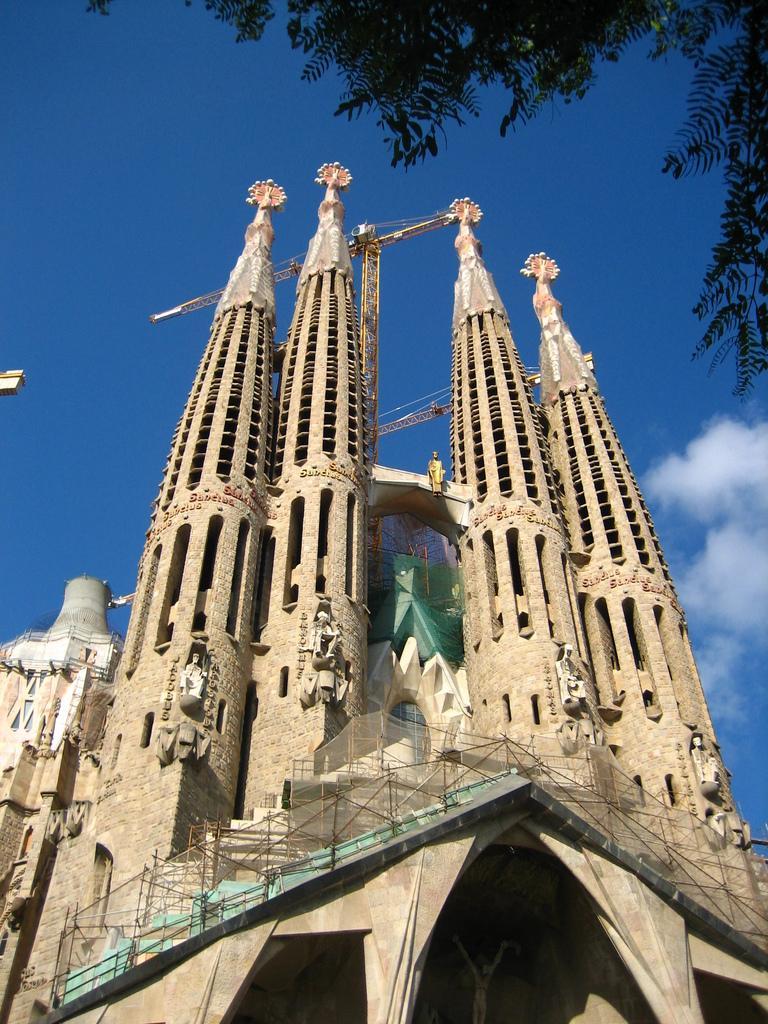In one or two sentences, can you explain what this image depicts? In the picture I can see building towers, sculptures on the building, a bridge and some other objects. In the background I can see the sky. 